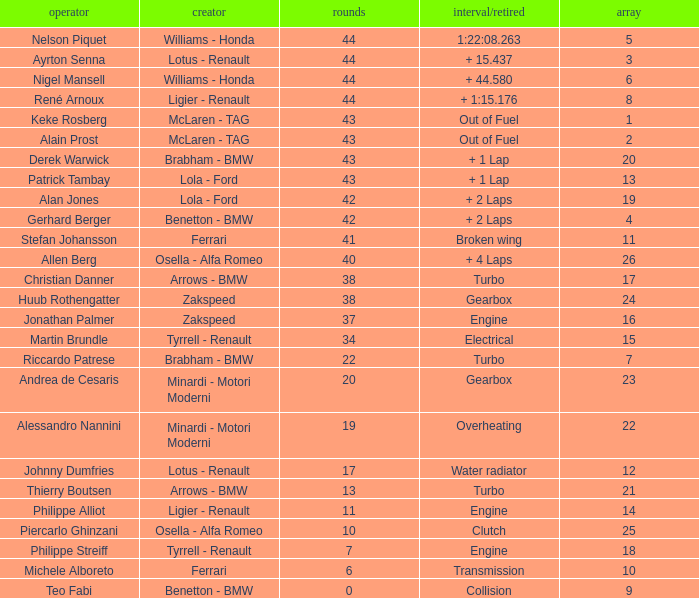Tell me the time/retired for Laps of 42 and Grids of 4 + 2 Laps. 